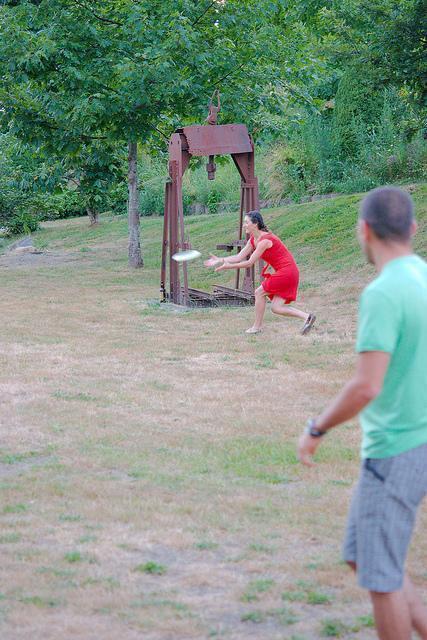What is the woman in red reaching towards?
Make your selection and explain in format: 'Answer: answer
Rationale: rationale.'
Options: Frisbee, cat, baby, dog. Answer: frisbee.
Rationale: A woman is extending her hands out towards a disc that is in the air and approaching. 